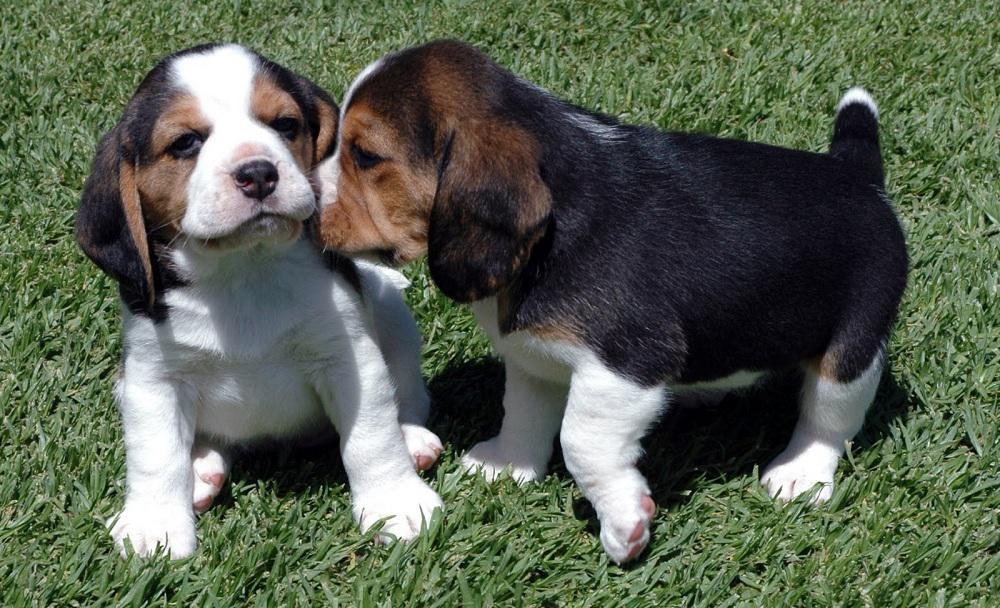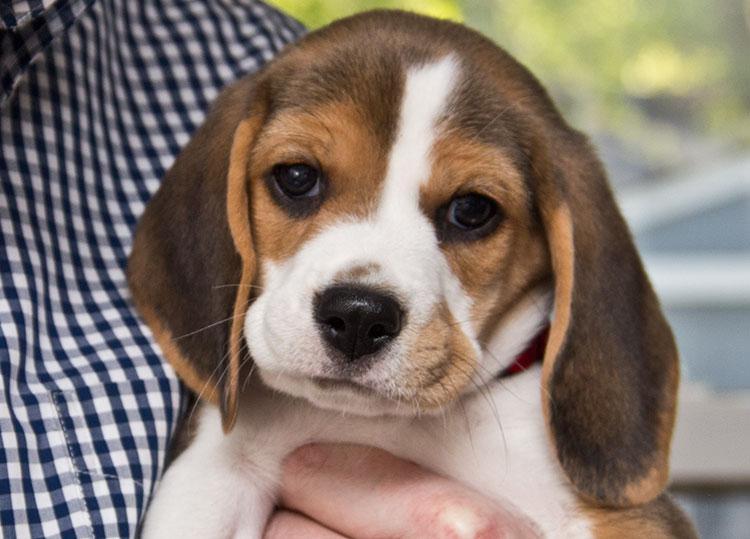The first image is the image on the left, the second image is the image on the right. For the images shown, is this caption "Two dogs pose together in the image on the left." true? Answer yes or no. Yes. The first image is the image on the left, the second image is the image on the right. Given the left and right images, does the statement "The left image contains exactly two puppies." hold true? Answer yes or no. Yes. 